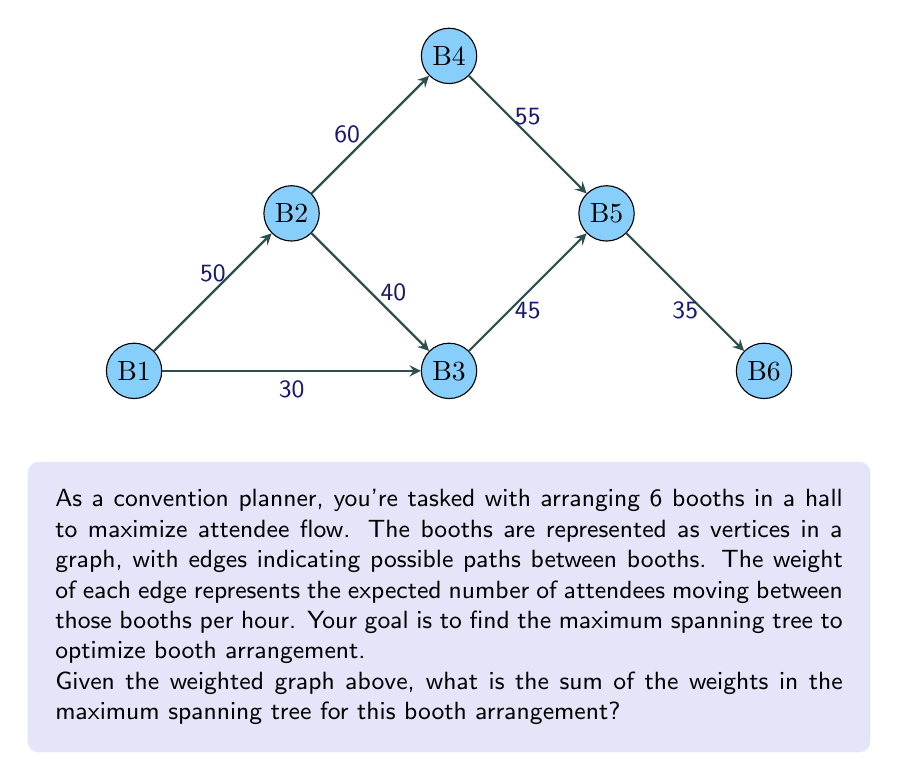What is the answer to this math problem? To solve this problem, we'll use Kruskal's algorithm to find the maximum spanning tree:

1) Sort the edges by weight in descending order:
   60 (B2-B4), 55 (B4-B5), 50 (B1-B2), 45 (B3-B5), 40 (B2-B3), 35 (B5-B6), 30 (B1-B3)

2) Add edges to the tree, skipping those that would create a cycle:
   
   a) Add 60 (B2-B4)
   b) Add 55 (B4-B5)
   c) Add 50 (B1-B2)
   d) Add 45 (B3-B5)
   e) Add 35 (B5-B6)

3) We stop here as we have included 5 edges, which is sufficient for a spanning tree of 6 vertices (n-1 edges, where n is the number of vertices).

4) Sum the weights of the selected edges:
   $$60 + 55 + 50 + 45 + 35 = 245$$

Therefore, the maximum spanning tree has a total weight of 245, representing the optimal arrangement of booths to maximize attendee flow.
Answer: 245 